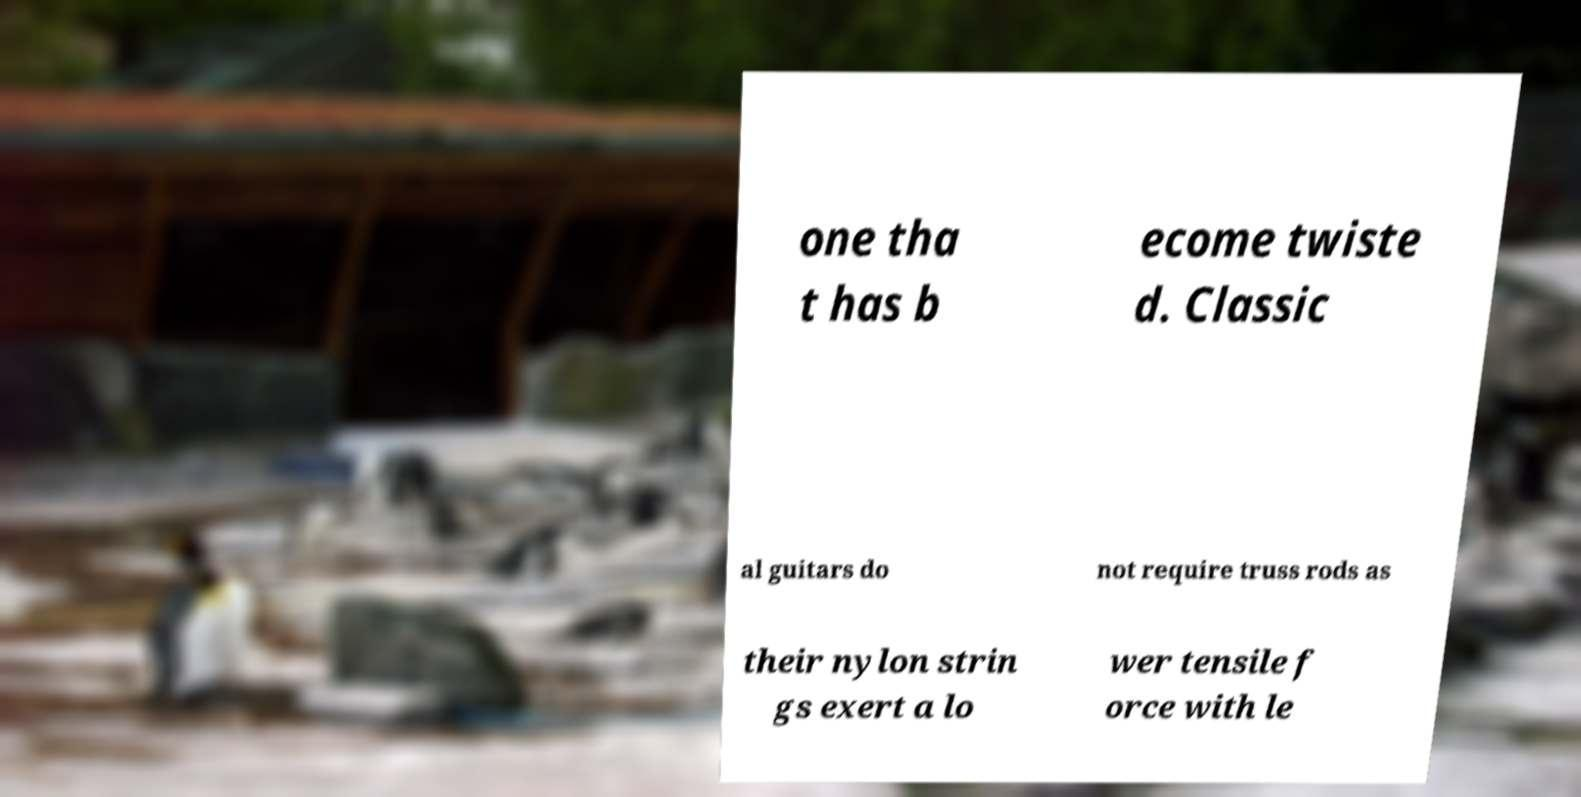What messages or text are displayed in this image? I need them in a readable, typed format. one tha t has b ecome twiste d. Classic al guitars do not require truss rods as their nylon strin gs exert a lo wer tensile f orce with le 